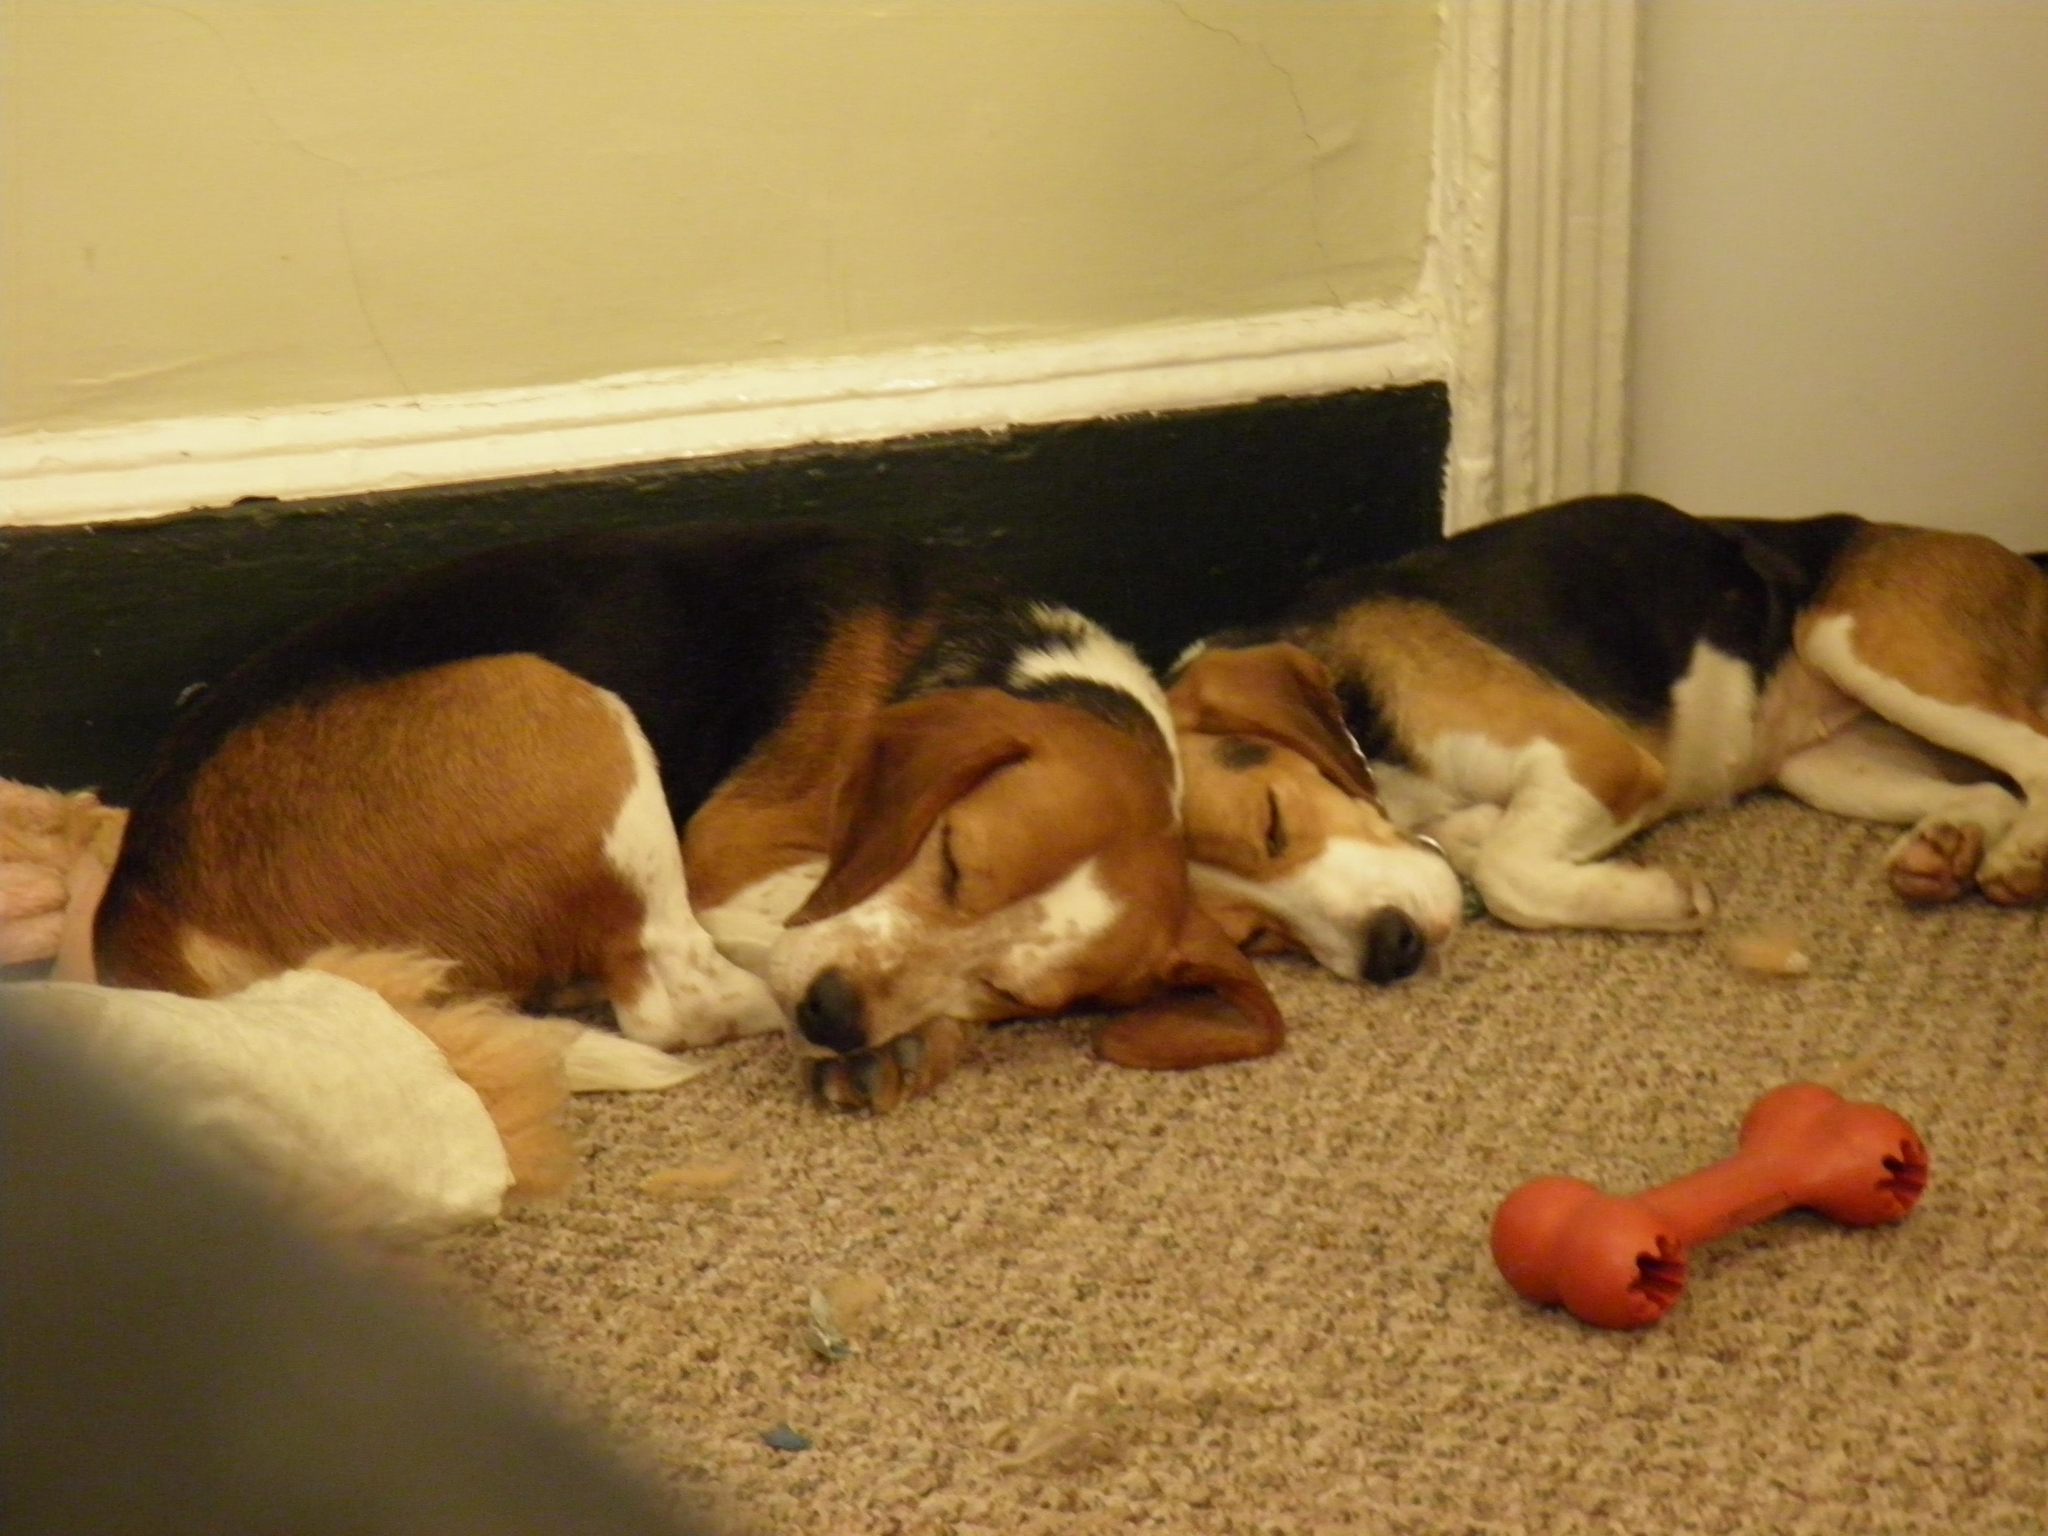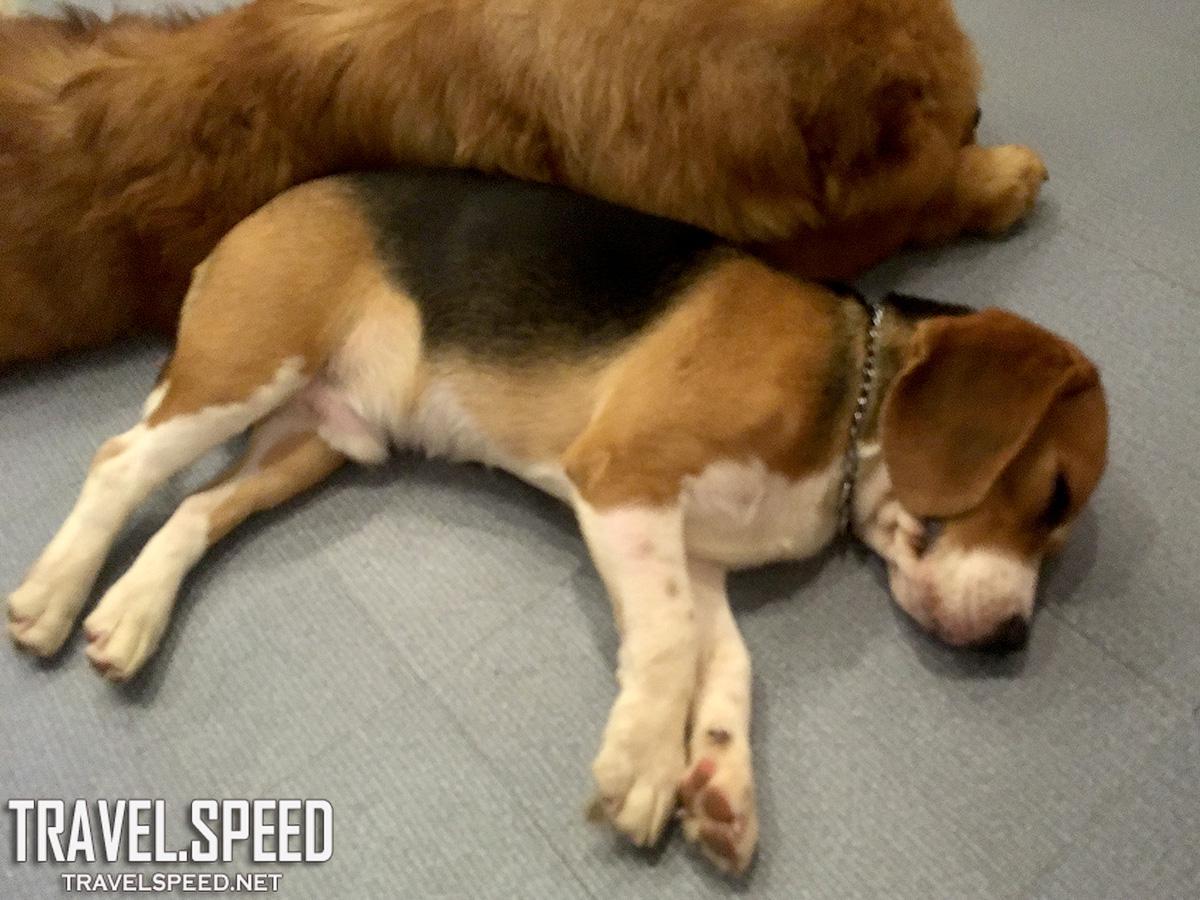The first image is the image on the left, the second image is the image on the right. Evaluate the accuracy of this statement regarding the images: "One puppy is holding a stuffed animal.". Is it true? Answer yes or no. No. The first image is the image on the left, the second image is the image on the right. Evaluate the accuracy of this statement regarding the images: "In one image a dog lying on its side has a front leg over a stuffed animal which it has pulled close, while in a second image, at least two dogs are sleeping.". Is it true? Answer yes or no. No. 